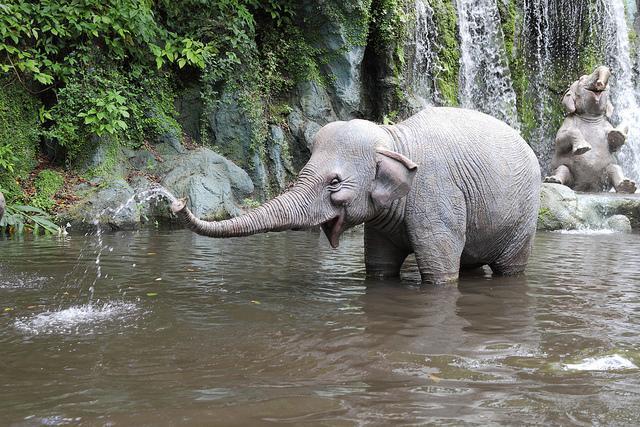How many elephants are in the photo?
Give a very brief answer. 2. How many keyboards are there?
Give a very brief answer. 0. 